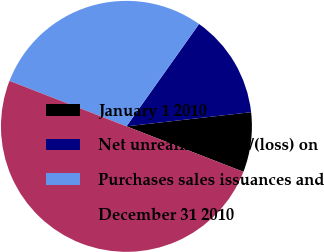Convert chart to OTSL. <chart><loc_0><loc_0><loc_500><loc_500><pie_chart><fcel>January 1 2010<fcel>Net unrealized gain/(loss) on<fcel>Purchases sales issuances and<fcel>December 31 2010<nl><fcel>7.7%<fcel>13.38%<fcel>28.92%<fcel>50.0%<nl></chart> 